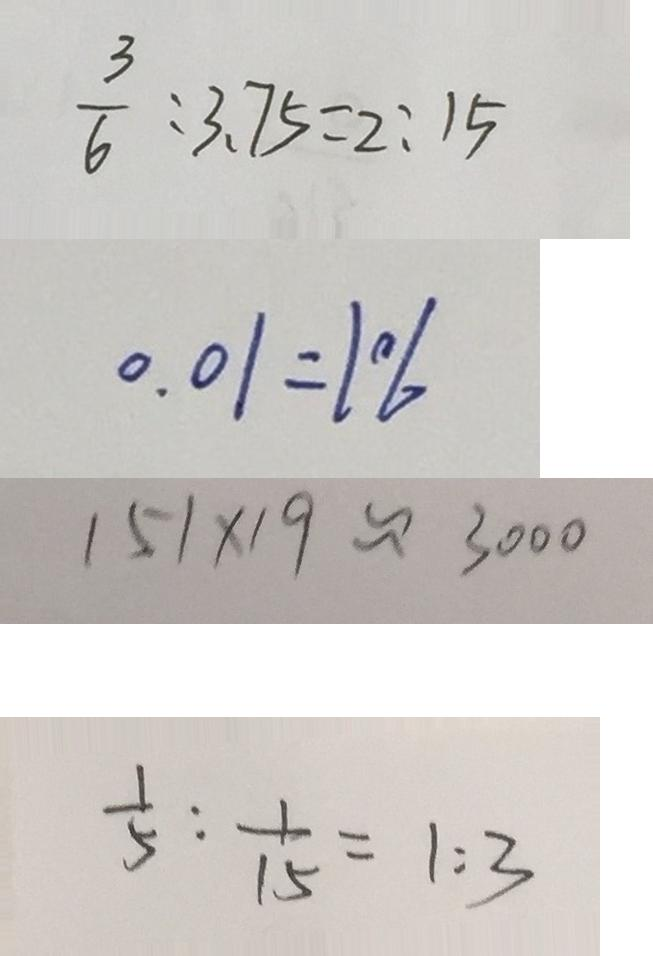<formula> <loc_0><loc_0><loc_500><loc_500>\frac { 3 } { 6 } : 3 . 7 5 = 2 : 1 5 
 0 . 0 1 = 1 \% 
 1 5 1 \times 1 9 \approx 3 0 0 0 
 \frac { 1 } { 5 } : \frac { 1 } { 1 5 } = 1 : 3</formula> 